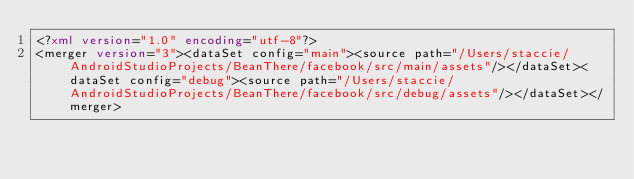<code> <loc_0><loc_0><loc_500><loc_500><_XML_><?xml version="1.0" encoding="utf-8"?>
<merger version="3"><dataSet config="main"><source path="/Users/staccie/AndroidStudioProjects/BeanThere/facebook/src/main/assets"/></dataSet><dataSet config="debug"><source path="/Users/staccie/AndroidStudioProjects/BeanThere/facebook/src/debug/assets"/></dataSet></merger></code> 